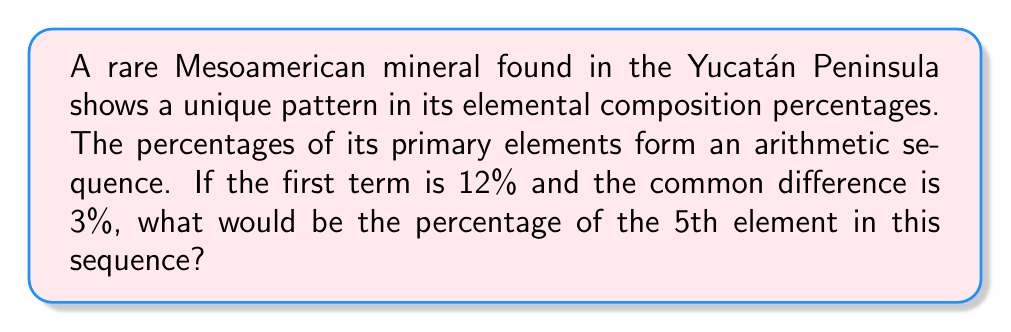Teach me how to tackle this problem. To solve this problem, we need to understand the properties of an arithmetic sequence and apply them to the given information.

1. In an arithmetic sequence, the difference between any two consecutive terms is constant. This constant is called the common difference.

2. The formula for the nth term of an arithmetic sequence is:
   $a_n = a_1 + (n - 1)d$
   Where:
   $a_n$ is the nth term
   $a_1$ is the first term
   $n$ is the position of the term
   $d$ is the common difference

3. We are given:
   $a_1 = 12\%$ (first term)
   $d = 3\%$ (common difference)
   We need to find $a_5$ (5th term)

4. Plugging these values into the formula:
   $a_5 = a_1 + (5 - 1)d$
   $a_5 = 12\% + (4)(3\%)$
   $a_5 = 12\% + 12\%$
   $a_5 = 24\%$

Therefore, the percentage of the 5th element in the sequence would be 24%.
Answer: 24% 